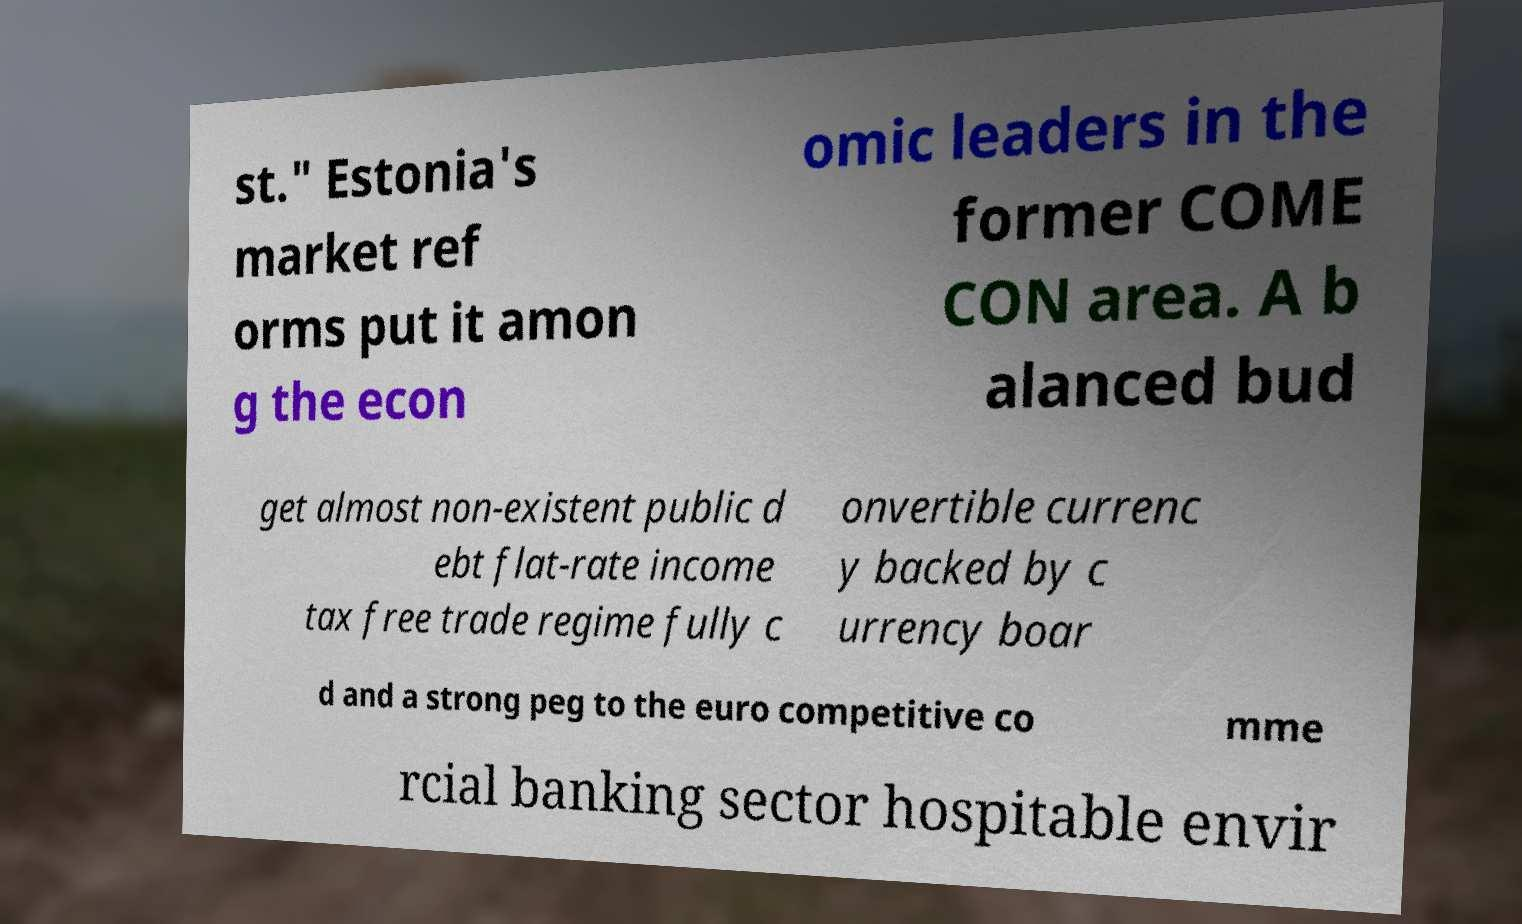Please identify and transcribe the text found in this image. st." Estonia's market ref orms put it amon g the econ omic leaders in the former COME CON area. A b alanced bud get almost non-existent public d ebt flat-rate income tax free trade regime fully c onvertible currenc y backed by c urrency boar d and a strong peg to the euro competitive co mme rcial banking sector hospitable envir 